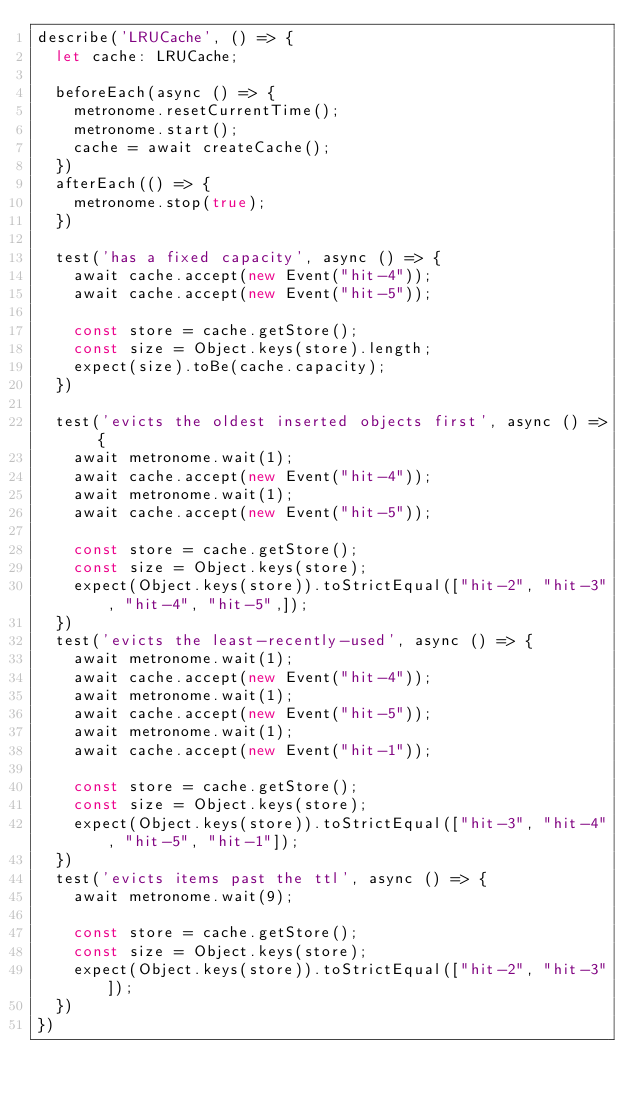Convert code to text. <code><loc_0><loc_0><loc_500><loc_500><_TypeScript_>describe('LRUCache', () => {
  let cache: LRUCache;

  beforeEach(async () => {
    metronome.resetCurrentTime();
    metronome.start();
    cache = await createCache();
  })
  afterEach(() => {
    metronome.stop(true);
  })

  test('has a fixed capacity', async () => {
    await cache.accept(new Event("hit-4"));
    await cache.accept(new Event("hit-5"));

    const store = cache.getStore();
    const size = Object.keys(store).length;
    expect(size).toBe(cache.capacity);
  })

  test('evicts the oldest inserted objects first', async () => {
    await metronome.wait(1);
    await cache.accept(new Event("hit-4"));
    await metronome.wait(1);
    await cache.accept(new Event("hit-5"));

    const store = cache.getStore();
    const size = Object.keys(store);
    expect(Object.keys(store)).toStrictEqual(["hit-2", "hit-3", "hit-4", "hit-5",]);
  })
  test('evicts the least-recently-used', async () => {
    await metronome.wait(1);
    await cache.accept(new Event("hit-4"));
    await metronome.wait(1);
    await cache.accept(new Event("hit-5"));
    await metronome.wait(1);
    await cache.accept(new Event("hit-1"));

    const store = cache.getStore();
    const size = Object.keys(store);
    expect(Object.keys(store)).toStrictEqual(["hit-3", "hit-4", "hit-5", "hit-1"]);
  })
  test('evicts items past the ttl', async () => {
    await metronome.wait(9);

    const store = cache.getStore();
    const size = Object.keys(store);
    expect(Object.keys(store)).toStrictEqual(["hit-2", "hit-3"]);
  })
})

</code> 